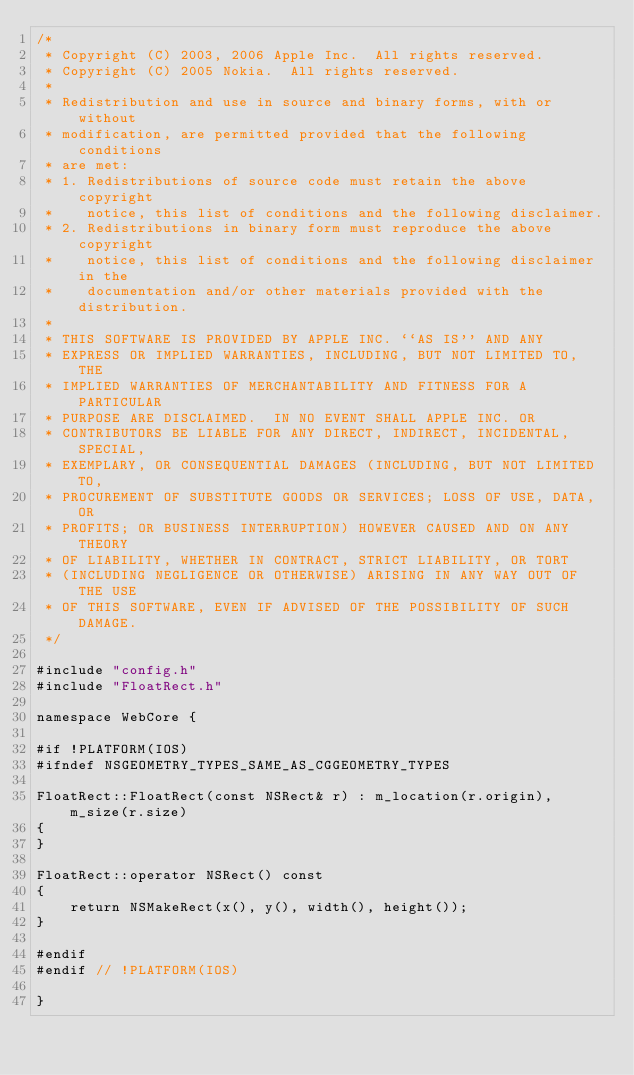<code> <loc_0><loc_0><loc_500><loc_500><_ObjectiveC_>/*
 * Copyright (C) 2003, 2006 Apple Inc.  All rights reserved.
 * Copyright (C) 2005 Nokia.  All rights reserved.
 *
 * Redistribution and use in source and binary forms, with or without
 * modification, are permitted provided that the following conditions
 * are met:
 * 1. Redistributions of source code must retain the above copyright
 *    notice, this list of conditions and the following disclaimer.
 * 2. Redistributions in binary form must reproduce the above copyright
 *    notice, this list of conditions and the following disclaimer in the
 *    documentation and/or other materials provided with the distribution.
 *
 * THIS SOFTWARE IS PROVIDED BY APPLE INC. ``AS IS'' AND ANY
 * EXPRESS OR IMPLIED WARRANTIES, INCLUDING, BUT NOT LIMITED TO, THE
 * IMPLIED WARRANTIES OF MERCHANTABILITY AND FITNESS FOR A PARTICULAR
 * PURPOSE ARE DISCLAIMED.  IN NO EVENT SHALL APPLE INC. OR
 * CONTRIBUTORS BE LIABLE FOR ANY DIRECT, INDIRECT, INCIDENTAL, SPECIAL,
 * EXEMPLARY, OR CONSEQUENTIAL DAMAGES (INCLUDING, BUT NOT LIMITED TO,
 * PROCUREMENT OF SUBSTITUTE GOODS OR SERVICES; LOSS OF USE, DATA, OR
 * PROFITS; OR BUSINESS INTERRUPTION) HOWEVER CAUSED AND ON ANY THEORY
 * OF LIABILITY, WHETHER IN CONTRACT, STRICT LIABILITY, OR TORT
 * (INCLUDING NEGLIGENCE OR OTHERWISE) ARISING IN ANY WAY OUT OF THE USE
 * OF THIS SOFTWARE, EVEN IF ADVISED OF THE POSSIBILITY OF SUCH DAMAGE.
 */

#include "config.h"
#include "FloatRect.h"

namespace WebCore {

#if !PLATFORM(IOS)
#ifndef NSGEOMETRY_TYPES_SAME_AS_CGGEOMETRY_TYPES

FloatRect::FloatRect(const NSRect& r) : m_location(r.origin), m_size(r.size)
{
}

FloatRect::operator NSRect() const
{
    return NSMakeRect(x(), y(), width(), height());
}

#endif
#endif // !PLATFORM(IOS)

}
</code> 